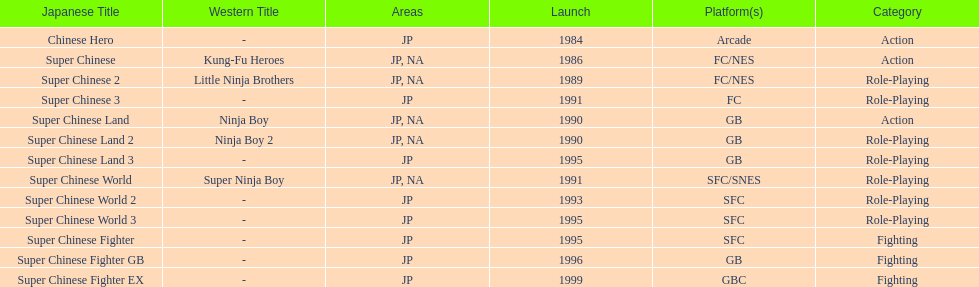Which platforms had the most titles released? GB. 